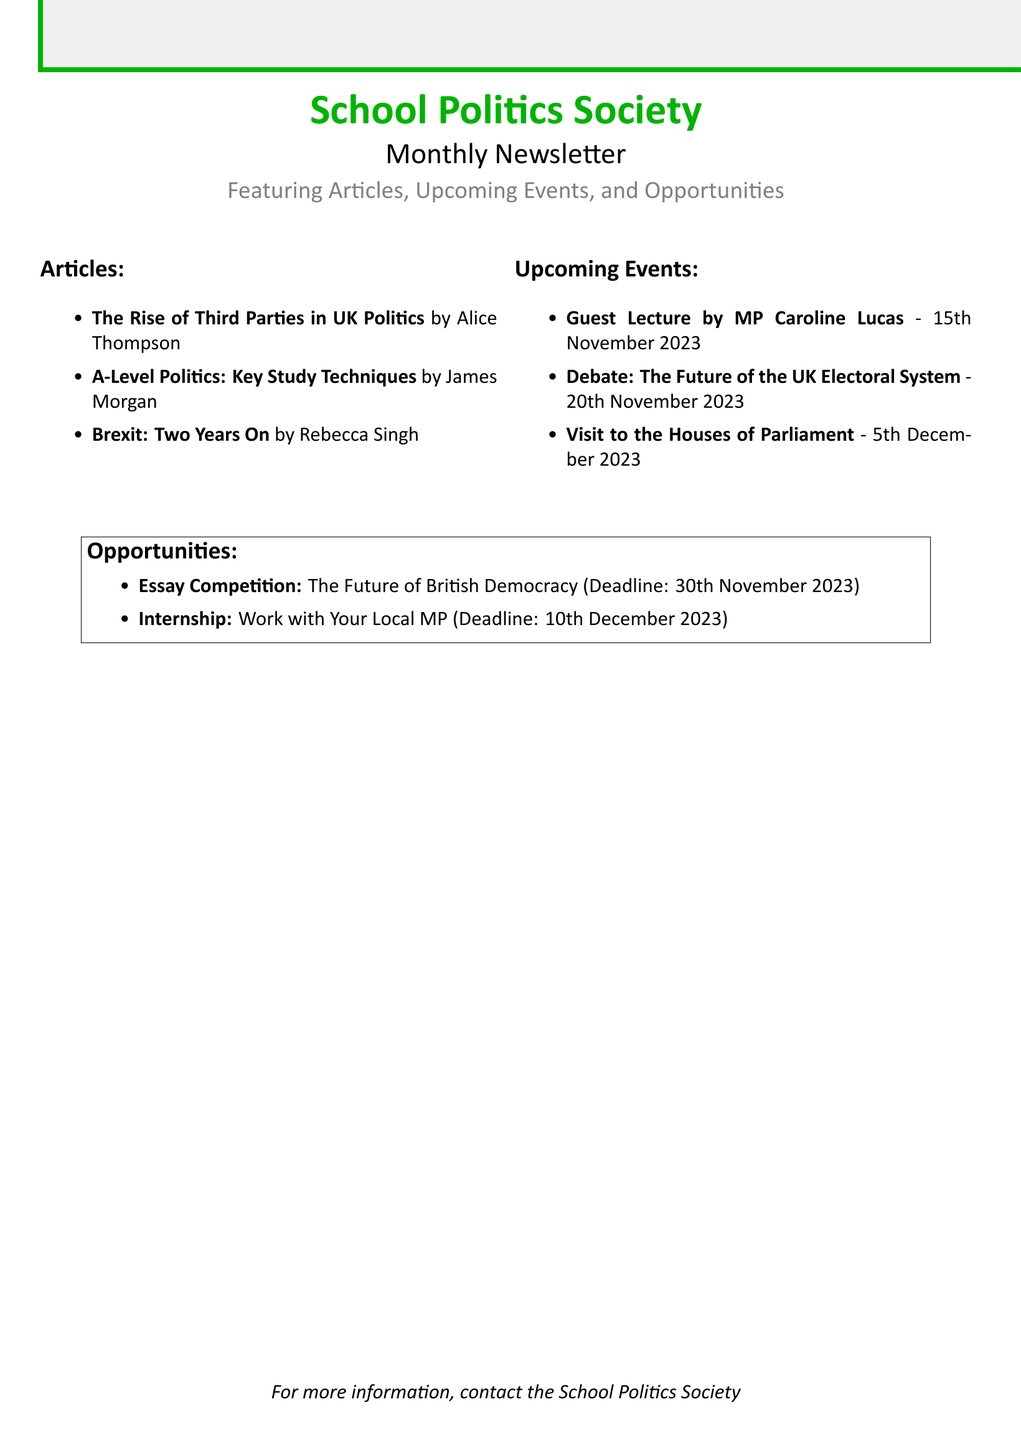What is the title of the newsletter? The title is prominently featured at the top of the document, stating "Monthly Newsletter".
Answer: Monthly Newsletter Who wrote the article on Brexit? The document lists authors next to their respective articles, and "Brexit: Two Years On" is by Rebecca Singh.
Answer: Rebecca Singh When is the guest lecture by MP Caroline Lucas scheduled? The date for the guest lecture is specifically mentioned in the upcoming events section as 15th November 2023.
Answer: 15th November 2023 What is the deadline for the essay competition? The deadline for the essay competition is explicitly stated in the opportunities section of the document as 30th November 2023.
Answer: 30th November 2023 What is one of the articles featured in the newsletter? The articles are listed under the articles section, one of which is "The Rise of Third Parties in UK Politics".
Answer: The Rise of Third Parties in UK Politics What event is scheduled for 5th December 2023? The document indicates the visit to the Houses of Parliament on this date under upcoming events.
Answer: Visit to the Houses of Parliament How many articles are mentioned in the newsletter? The articles section lists three titles, thus the total is three.
Answer: Three What is the internship opportunity mentioned in the newsletter? The opportunities section describes an internship to work with a local MP.
Answer: Work with Your Local MP Who is presenting the debate on the future of the UK electoral system? The document states a debate event, but it does not mention a specific presenter for the debate.
Answer: Not specified 